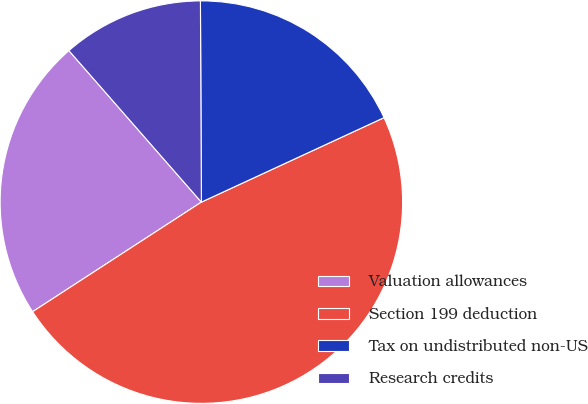<chart> <loc_0><loc_0><loc_500><loc_500><pie_chart><fcel>Valuation allowances<fcel>Section 199 deduction<fcel>Tax on undistributed non-US<fcel>Research credits<nl><fcel>22.73%<fcel>47.73%<fcel>18.18%<fcel>11.36%<nl></chart> 